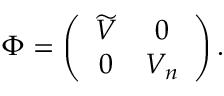Convert formula to latex. <formula><loc_0><loc_0><loc_500><loc_500>\Phi = \left ( \begin{array} { c c } { { \widetilde { V } } } & { 0 } \\ { 0 } & { { V _ { n } } } \end{array} \right ) .</formula> 